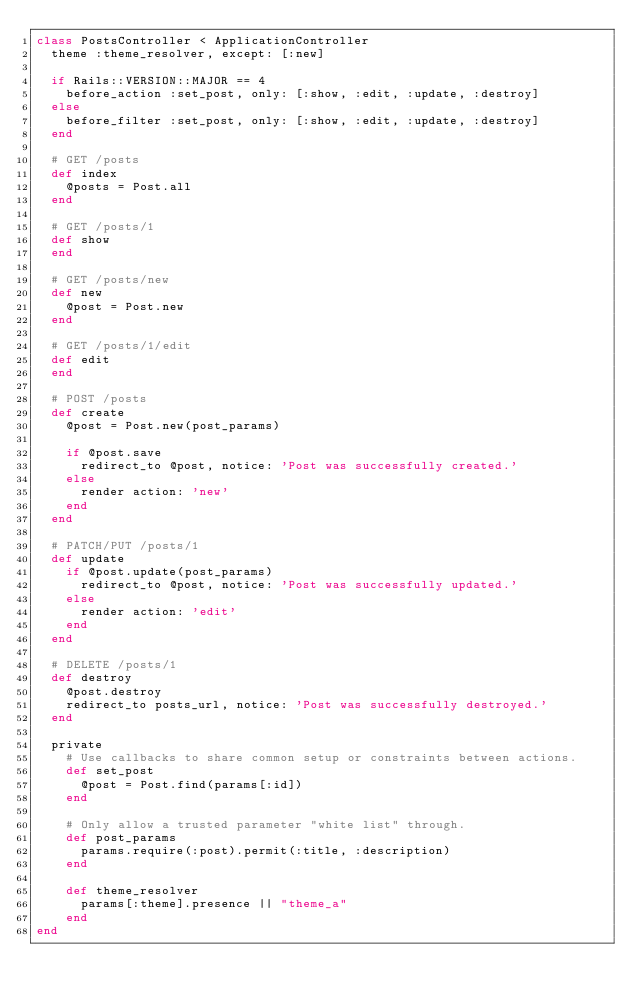Convert code to text. <code><loc_0><loc_0><loc_500><loc_500><_Ruby_>class PostsController < ApplicationController
  theme :theme_resolver, except: [:new]

  if Rails::VERSION::MAJOR == 4
    before_action :set_post, only: [:show, :edit, :update, :destroy]
  else
    before_filter :set_post, only: [:show, :edit, :update, :destroy]
  end

  # GET /posts
  def index
    @posts = Post.all
  end

  # GET /posts/1
  def show
  end

  # GET /posts/new
  def new
    @post = Post.new
  end

  # GET /posts/1/edit
  def edit
  end

  # POST /posts
  def create
    @post = Post.new(post_params)

    if @post.save
      redirect_to @post, notice: 'Post was successfully created.'
    else
      render action: 'new'
    end
  end

  # PATCH/PUT /posts/1
  def update
    if @post.update(post_params)
      redirect_to @post, notice: 'Post was successfully updated.'
    else
      render action: 'edit'
    end
  end

  # DELETE /posts/1
  def destroy
    @post.destroy
    redirect_to posts_url, notice: 'Post was successfully destroyed.'
  end

  private
    # Use callbacks to share common setup or constraints between actions.
    def set_post
      @post = Post.find(params[:id])
    end

    # Only allow a trusted parameter "white list" through.
    def post_params
      params.require(:post).permit(:title, :description)
    end

    def theme_resolver
      params[:theme].presence || "theme_a"
    end
end
</code> 